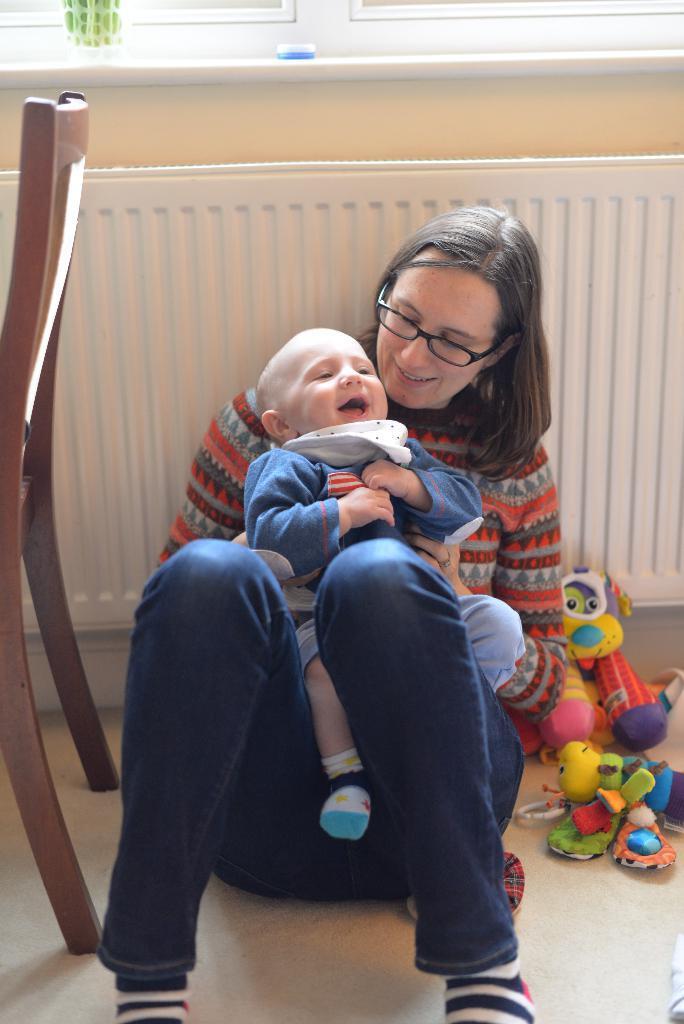Describe this image in one or two sentences. In this image I can see a woman is sitting alone with baby on the floor. I can also see there is a chair and few toys on the floor. 